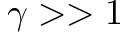Convert formula to latex. <formula><loc_0><loc_0><loc_500><loc_500>\gamma > > 1</formula> 